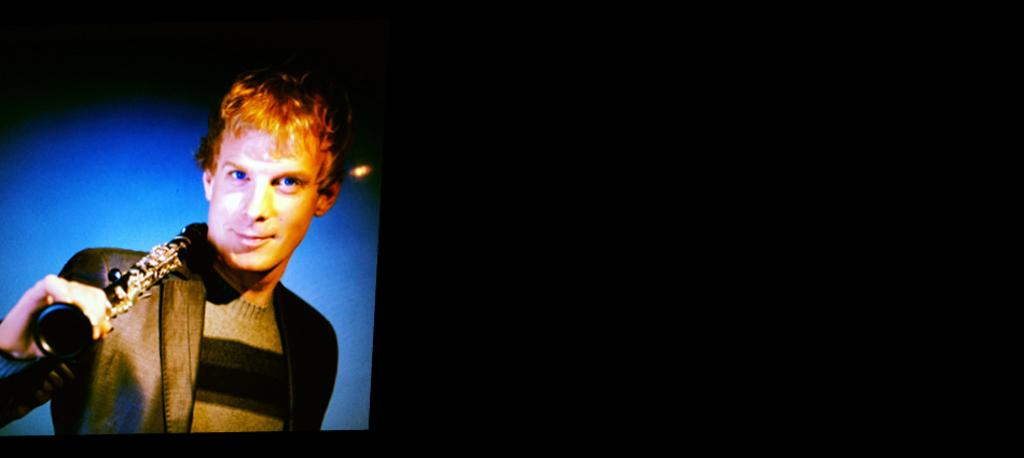What is the main object in the image? There is a screen in the image. What can be seen on the screen? A man holding a music instrument is visible on the screen. How would you describe the overall lighting in the image? The background of the image is dark. Where is the secretary sitting in the image? There is no secretary present in the image. What type of ants can be seen crawling on the man's instrument in the image? There are no ants present in the image. 